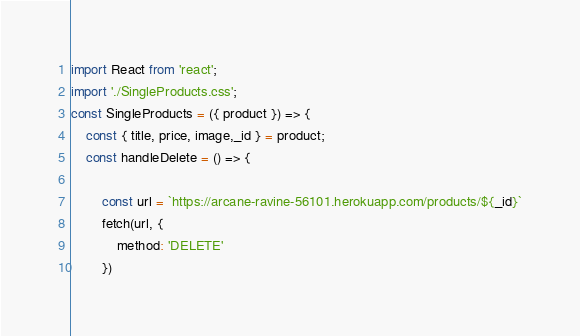<code> <loc_0><loc_0><loc_500><loc_500><_JavaScript_>import React from 'react';
import './SingleProducts.css';
const SingleProducts = ({ product }) => {
    const { title, price, image,_id } = product;
    const handleDelete = () => {

        const url = `https://arcane-ravine-56101.herokuapp.com/products/${_id}`
        fetch(url, {
            method: 'DELETE'
        })</code> 